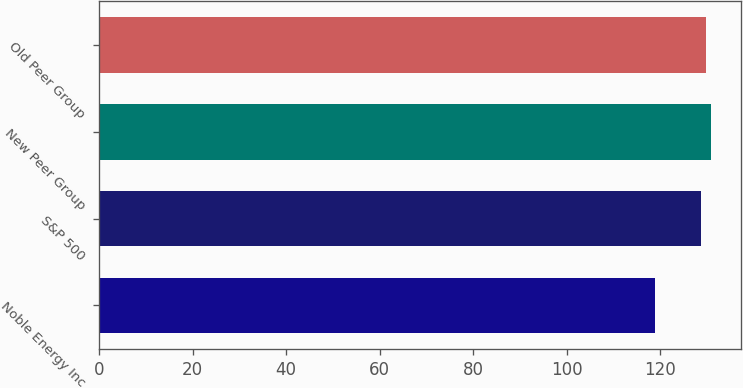<chart> <loc_0><loc_0><loc_500><loc_500><bar_chart><fcel>Noble Energy Inc<fcel>S&P 500<fcel>New Peer Group<fcel>Old Peer Group<nl><fcel>118.88<fcel>128.68<fcel>130.86<fcel>129.77<nl></chart> 